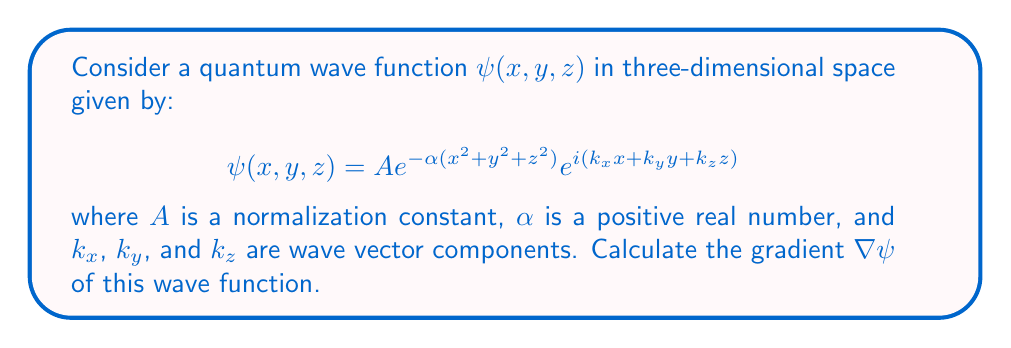Solve this math problem. To calculate the gradient of the wave function, we need to find the partial derivatives with respect to x, y, and z:

1. First, let's rewrite the wave function in a more compact form:
   $$\psi(x, y, z) = Ae^{-\alpha r^2}e^{i\mathbf{k}\cdot\mathbf{r}}$$
   where $r^2 = x^2 + y^2 + z^2$ and $\mathbf{k}\cdot\mathbf{r} = k_xx + k_yy + k_zz$

2. Now, let's calculate the partial derivative with respect to x:
   $$\frac{\partial\psi}{\partial x} = Ae^{-\alpha r^2}e^{i\mathbf{k}\cdot\mathbf{r}} \cdot (-2\alpha x + ik_x)$$

3. Similarly for y and z:
   $$\frac{\partial\psi}{\partial y} = Ae^{-\alpha r^2}e^{i\mathbf{k}\cdot\mathbf{r}} \cdot (-2\alpha y + ik_y)$$
   $$\frac{\partial\psi}{\partial z} = Ae^{-\alpha r^2}e^{i\mathbf{k}\cdot\mathbf{r}} \cdot (-2\alpha z + ik_z)$$

4. The gradient is the vector of these partial derivatives:
   $$\nabla\psi = \left(\frac{\partial\psi}{\partial x}, \frac{\partial\psi}{\partial y}, \frac{\partial\psi}{\partial z}\right)$$

5. Substituting the partial derivatives:
   $$\nabla\psi = Ae^{-\alpha r^2}e^{i\mathbf{k}\cdot\mathbf{r}} \cdot (-2\alpha x + ik_x, -2\alpha y + ik_y, -2\alpha z + ik_z)$$

6. We can factor out the common term:
   $$\nabla\psi = Ae^{-\alpha r^2}e^{i\mathbf{k}\cdot\mathbf{r}} \cdot (-2\alpha\mathbf{r} + i\mathbf{k})$$

This is the gradient of the given quantum wave function in three-dimensional space.
Answer: $\nabla\psi = Ae^{-\alpha r^2}e^{i\mathbf{k}\cdot\mathbf{r}} \cdot (-2\alpha\mathbf{r} + i\mathbf{k})$ 